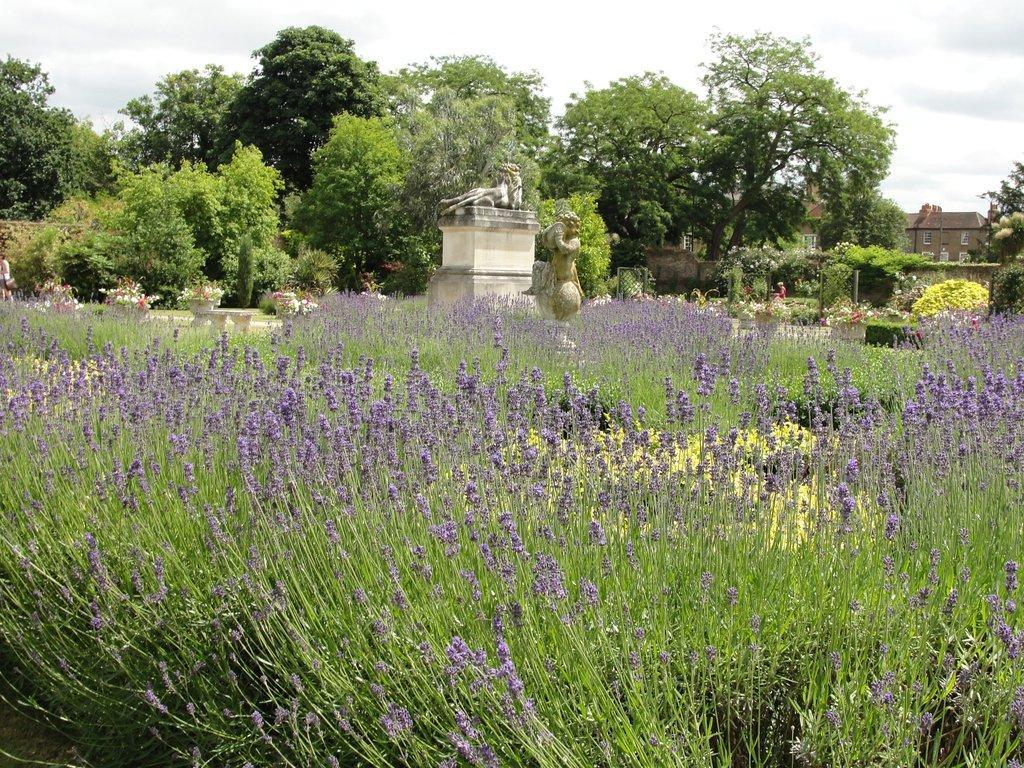Please provide a concise description of this image. In this image, we can see some trees, plants. Among them, we can see some plants in some objects. We can also see some statues, houses. We can see the ground with some grass and some objects. We can also see the sky and the fence. 